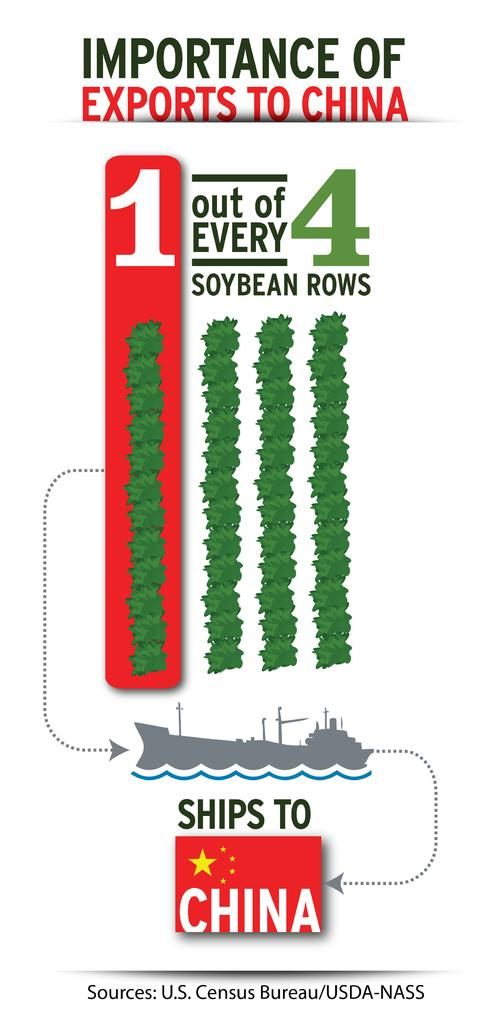Provide a one-sentence caption for the provided image. The image from the U.S. Census Bureau is about the importance of exports to China. 